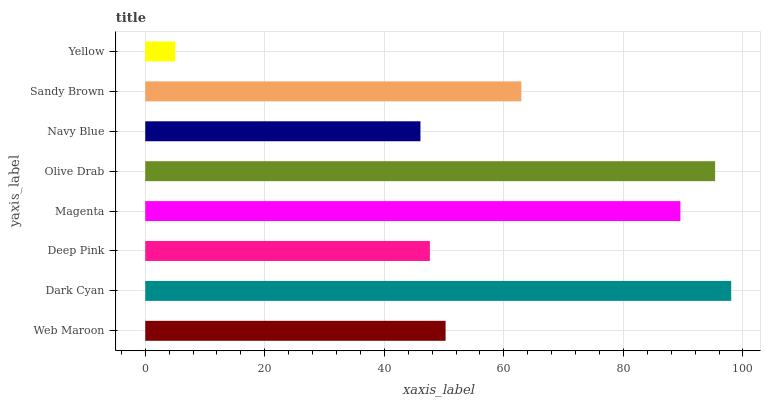Is Yellow the minimum?
Answer yes or no. Yes. Is Dark Cyan the maximum?
Answer yes or no. Yes. Is Deep Pink the minimum?
Answer yes or no. No. Is Deep Pink the maximum?
Answer yes or no. No. Is Dark Cyan greater than Deep Pink?
Answer yes or no. Yes. Is Deep Pink less than Dark Cyan?
Answer yes or no. Yes. Is Deep Pink greater than Dark Cyan?
Answer yes or no. No. Is Dark Cyan less than Deep Pink?
Answer yes or no. No. Is Sandy Brown the high median?
Answer yes or no. Yes. Is Web Maroon the low median?
Answer yes or no. Yes. Is Dark Cyan the high median?
Answer yes or no. No. Is Yellow the low median?
Answer yes or no. No. 